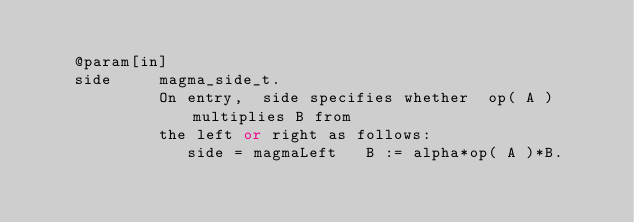<code> <loc_0><loc_0><loc_500><loc_500><_C++_>
    @param[in]
    side     magma_side_t.
             On entry,  side specifies whether  op( A ) multiplies B from 
             the left or right as follows:   
                side = magmaLeft   B := alpha*op( A )*B.   </code> 